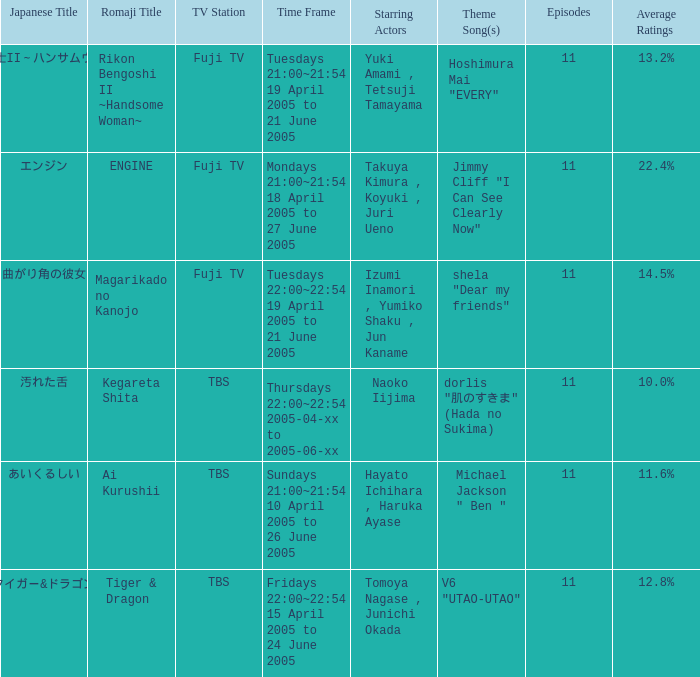Who is the protagonist of the show on thursdays 22:00~22:54 from 2005-04-xx to 2005-06-xx? Naoko Iijima. 